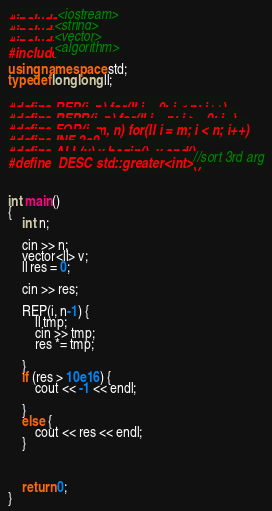Convert code to text. <code><loc_0><loc_0><loc_500><loc_500><_C++_>#include <iostream>
#include<string>
#include<vector>
#include<algorithm>

using namespace std;
typedef long long ll;

#define REP(i, n) for(ll i = 0; i < n; i++)
#define REPR(i, n) for(ll i = n; i >= 0; i--)
#define FOR(i, m, n) for(ll i = m; i < n; i++)
#define INF 2e9
#define ALL(v) v.begin(), v.end()
#define  DESC std::greater<int>() //sort 3rd arg



int main()
{
	int n;

	cin >> n;
	vector<ll> v;
	ll res = 0;

	cin >> res;

	REP(i, n-1) {
		ll tmp;
		cin >> tmp;
		res *= tmp;

	}
	if (res > 10e16) {
		cout << -1 << endl;

	}
	else {
		cout << res << endl;
	}
	
	

	return 0;
}

</code> 